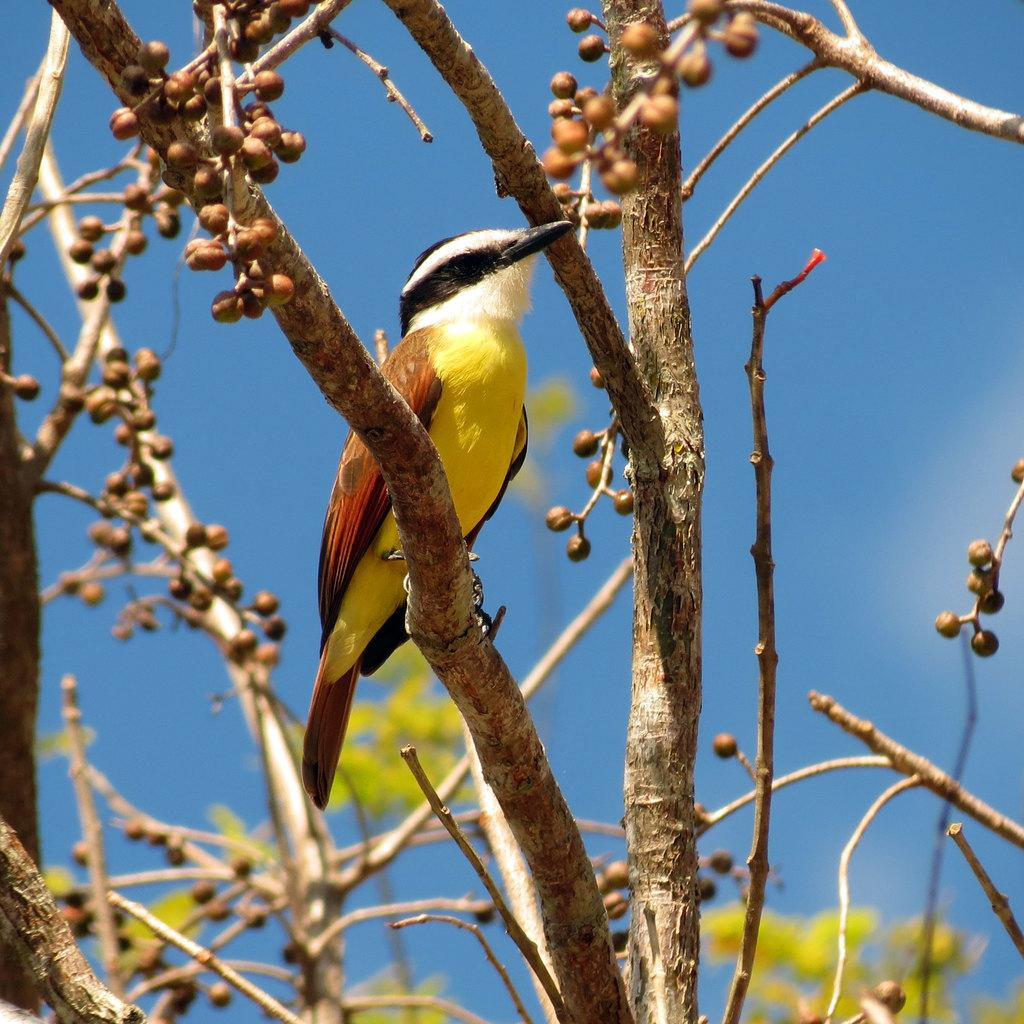What type of animal can be seen in the image? There is a bird in the image. Where is the bird located? The bird is on a tree stem. What else can be found on the tree stem? There are raw fruits on the tree stem. What type of attraction is the bird visiting in the image? There is no indication of an attraction in the image; it simply shows a bird on a tree stem with raw fruits. 